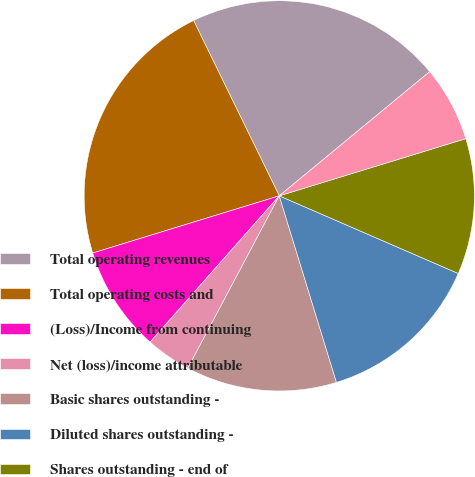Convert chart. <chart><loc_0><loc_0><loc_500><loc_500><pie_chart><fcel>Total operating revenues<fcel>Total operating costs and<fcel>(Loss)/Income from continuing<fcel>Net (loss)/income attributable<fcel>Basic shares outstanding -<fcel>Diluted shares outstanding -<fcel>Shares outstanding - end of<fcel>Book value<nl><fcel>21.25%<fcel>22.5%<fcel>8.75%<fcel>3.75%<fcel>12.5%<fcel>13.75%<fcel>11.25%<fcel>6.25%<nl></chart> 